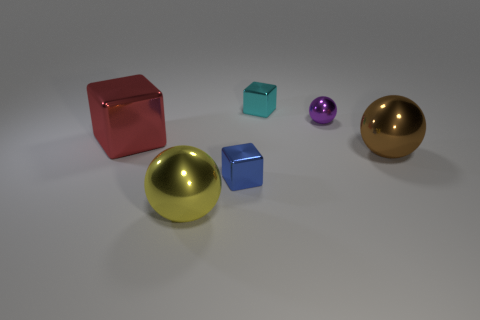Subtract all red spheres. Subtract all yellow cylinders. How many spheres are left? 3 Add 1 big cyan things. How many objects exist? 7 Subtract 0 gray cylinders. How many objects are left? 6 Subtract all small cyan shiny objects. Subtract all tiny things. How many objects are left? 2 Add 5 small cyan shiny cubes. How many small cyan shiny cubes are left? 6 Add 6 cyan cubes. How many cyan cubes exist? 7 